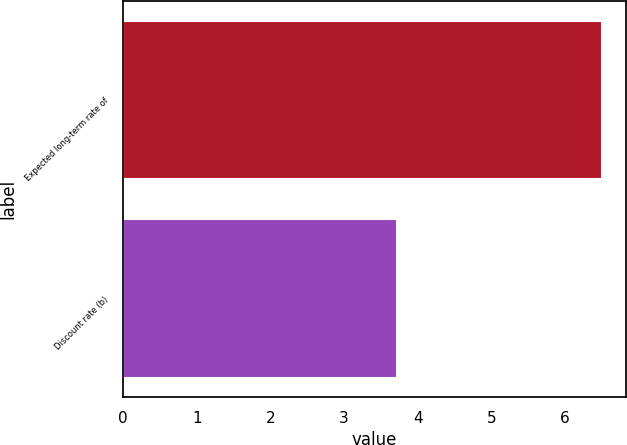<chart> <loc_0><loc_0><loc_500><loc_500><bar_chart><fcel>Expected long-term rate of<fcel>Discount rate (b)<nl><fcel>6.5<fcel>3.72<nl></chart> 